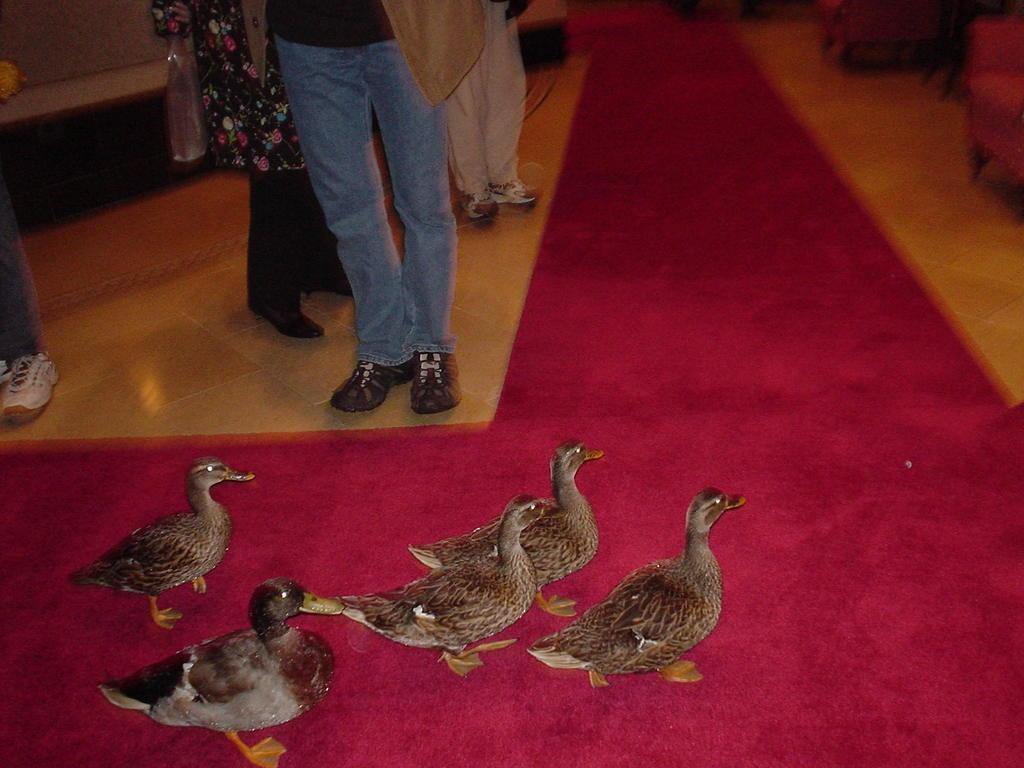In one or two sentences, can you explain what this image depicts? In this image we can see a group of ducks and some people standing on the floor. On the right side we can see some chairs. 